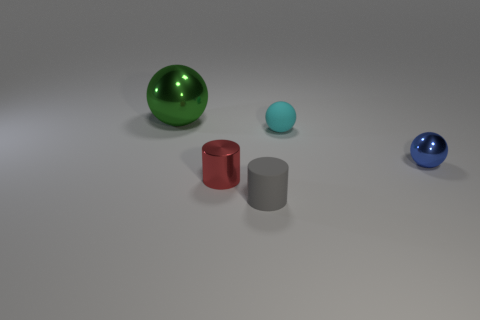What material is the red object?
Your response must be concise. Metal. Is the shape of the big green thing the same as the tiny metallic object on the left side of the gray cylinder?
Provide a short and direct response. No. There is a tiny ball right of the matte object that is behind the metallic ball that is in front of the large green metal object; what is it made of?
Your answer should be very brief. Metal. How many rubber spheres are there?
Keep it short and to the point. 1. What number of green objects are either big metallic spheres or cylinders?
Offer a terse response. 1. How many other objects are there of the same shape as the big green metallic thing?
Your answer should be compact. 2. Do the cylinder that is in front of the red shiny thing and the object to the right of the small cyan rubber thing have the same color?
Your answer should be very brief. No. How many small things are cyan objects or green metal balls?
Your response must be concise. 1. There is a green shiny object that is the same shape as the cyan thing; what size is it?
Give a very brief answer. Large. Is there any other thing that has the same size as the matte sphere?
Offer a very short reply. Yes. 